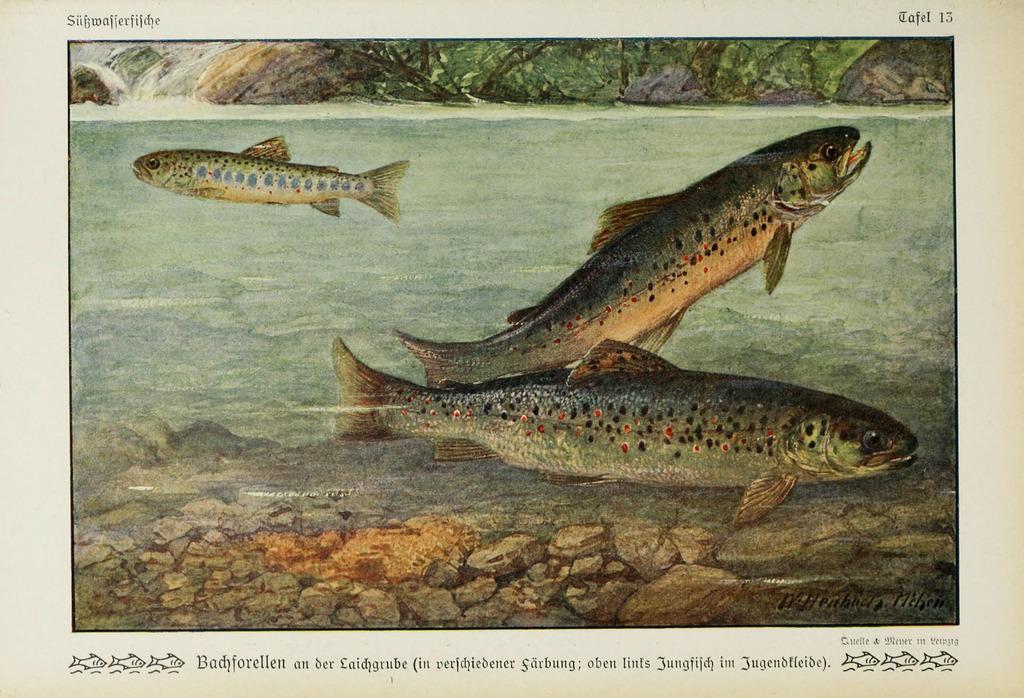Describe this image in one or two sentences. The picture is a painting. In the center of the picture there is a pond, in the pond there are fishes, water and stones. At the top there is a rock. At the bottom there is text. 